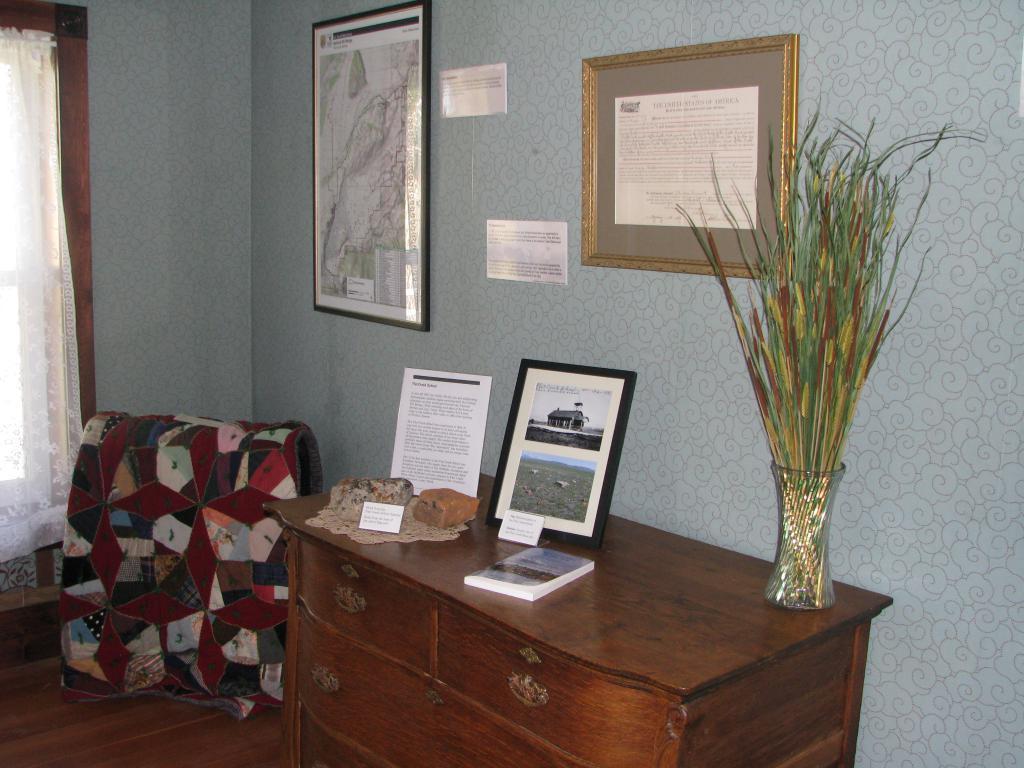In one or two sentences, can you explain what this image depicts? In this picture there is a inside view of the room. In the front there is a wooden box. On the top some photo frames and flower pot is placed. Behind we can see the wall with hanging photo frame. On the left side there is a door with white curtain. 